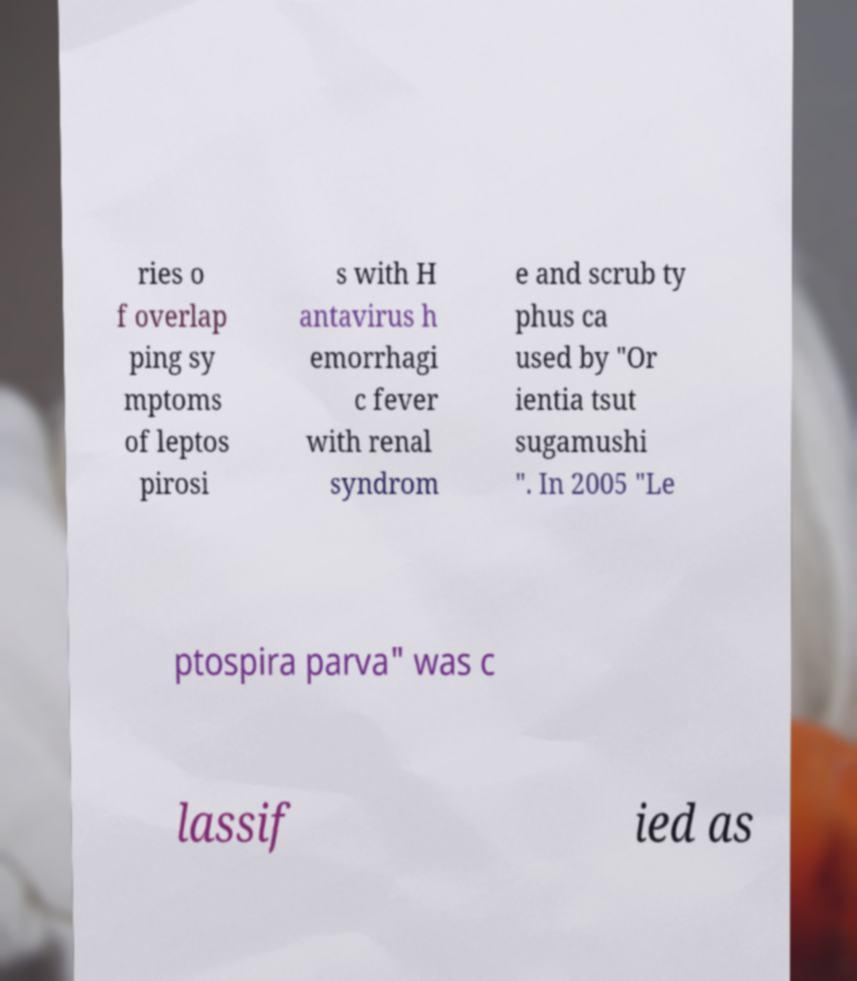Could you extract and type out the text from this image? ries o f overlap ping sy mptoms of leptos pirosi s with H antavirus h emorrhagi c fever with renal syndrom e and scrub ty phus ca used by "Or ientia tsut sugamushi ". In 2005 "Le ptospira parva" was c lassif ied as 